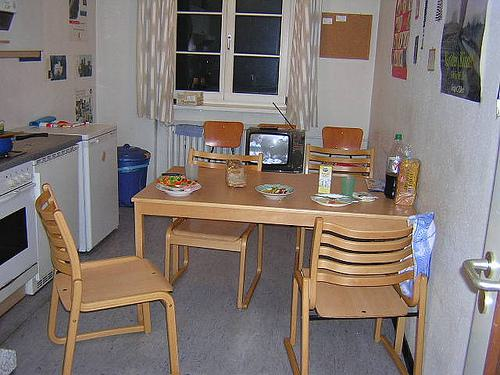How many chairs are there in the image? There are a total of five chairs visible in the image, arranged around a wooden table, contributing to the homely and functional setup of the room. 